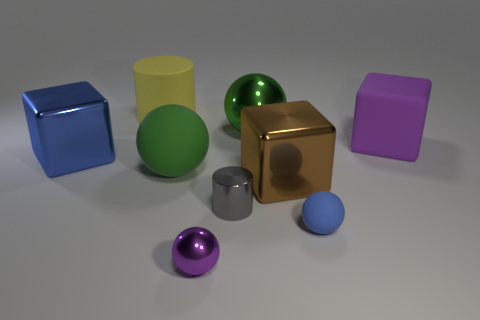There is a large block that is the same color as the tiny rubber ball; what is it made of?
Your answer should be compact. Metal. What number of other objects are there of the same color as the big rubber block?
Offer a terse response. 1. What shape is the small shiny object that is the same color as the large matte block?
Your answer should be compact. Sphere. What is the size of the yellow object on the right side of the cube left of the purple sphere that is to the left of the blue sphere?
Offer a very short reply. Large. What number of yellow objects are big metal spheres or matte things?
Give a very brief answer. 1. There is a purple thing that is left of the purple block; does it have the same shape as the brown thing?
Keep it short and to the point. No. Is the number of purple things to the left of the green rubber sphere greater than the number of large metallic spheres?
Offer a very short reply. No. How many blue matte objects are the same size as the purple metallic object?
Your answer should be very brief. 1. There is a metallic block that is the same color as the small rubber sphere; what size is it?
Your response must be concise. Large. What number of things are tiny purple metallic spheres or big cubes that are right of the purple ball?
Give a very brief answer. 3. 